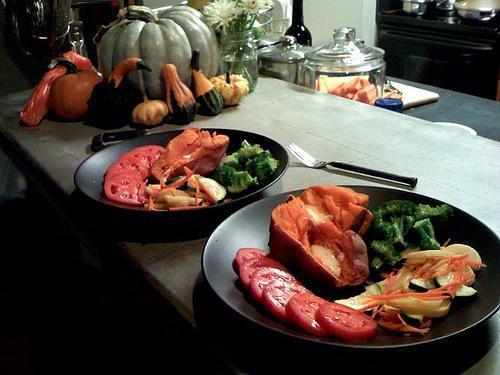How many forks?
Give a very brief answer. 1. 